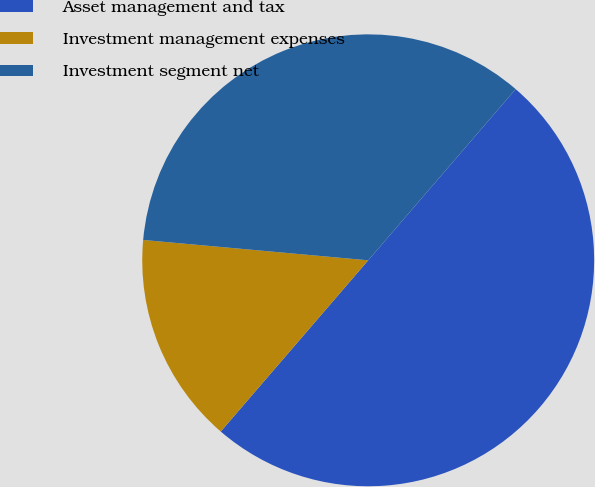Convert chart to OTSL. <chart><loc_0><loc_0><loc_500><loc_500><pie_chart><fcel>Asset management and tax<fcel>Investment management expenses<fcel>Investment segment net<nl><fcel>50.0%<fcel>15.12%<fcel>34.88%<nl></chart> 